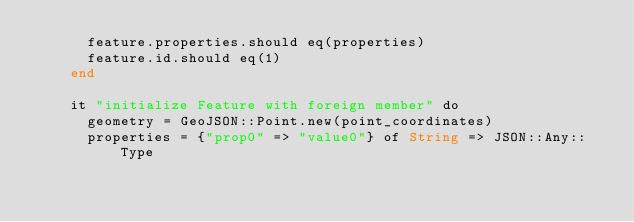<code> <loc_0><loc_0><loc_500><loc_500><_Crystal_>      feature.properties.should eq(properties)
      feature.id.should eq(1)
    end

    it "initialize Feature with foreign member" do
      geometry = GeoJSON::Point.new(point_coordinates)
      properties = {"prop0" => "value0"} of String => JSON::Any::Type
</code> 